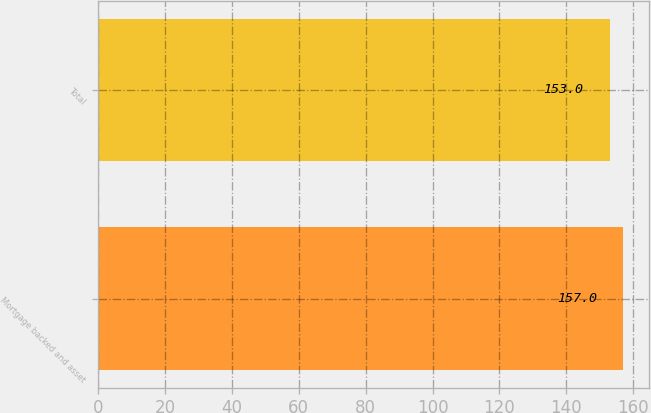Convert chart. <chart><loc_0><loc_0><loc_500><loc_500><bar_chart><fcel>Mortgage backed and asset<fcel>Total<nl><fcel>157<fcel>153<nl></chart> 